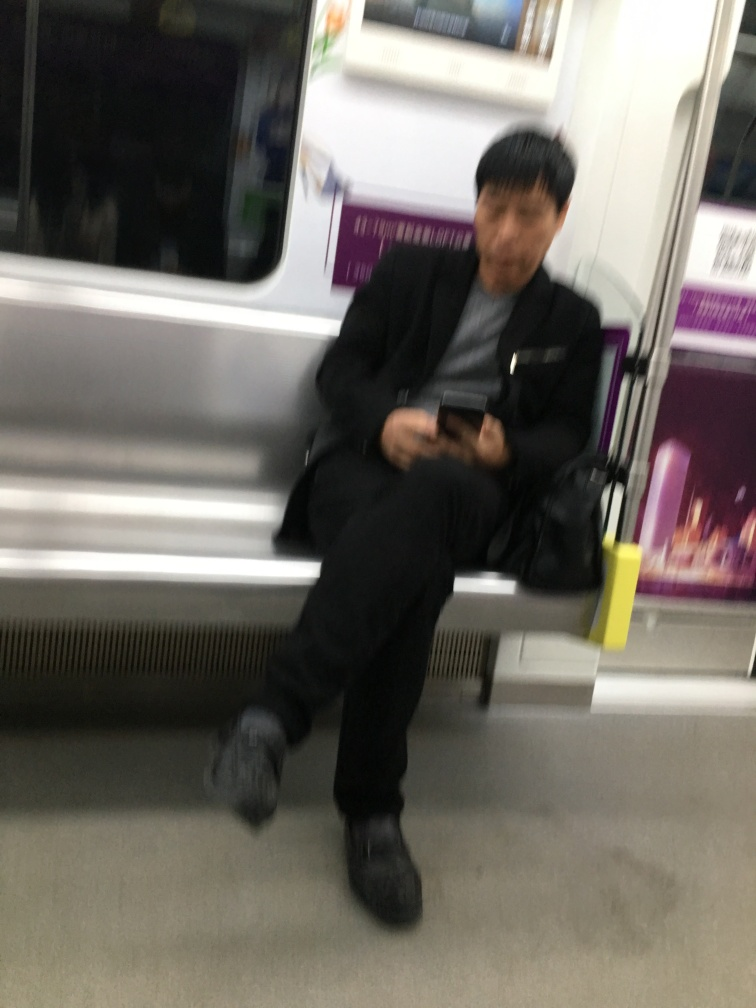Can you describe the setting of this image? The image depicts an individual seated inside a public transportation vehicle, likely a subway or train, with metal poles and seats characteristic of such a setting. The overall ambiance implies it might be a quiet moment during off-peak hours. 